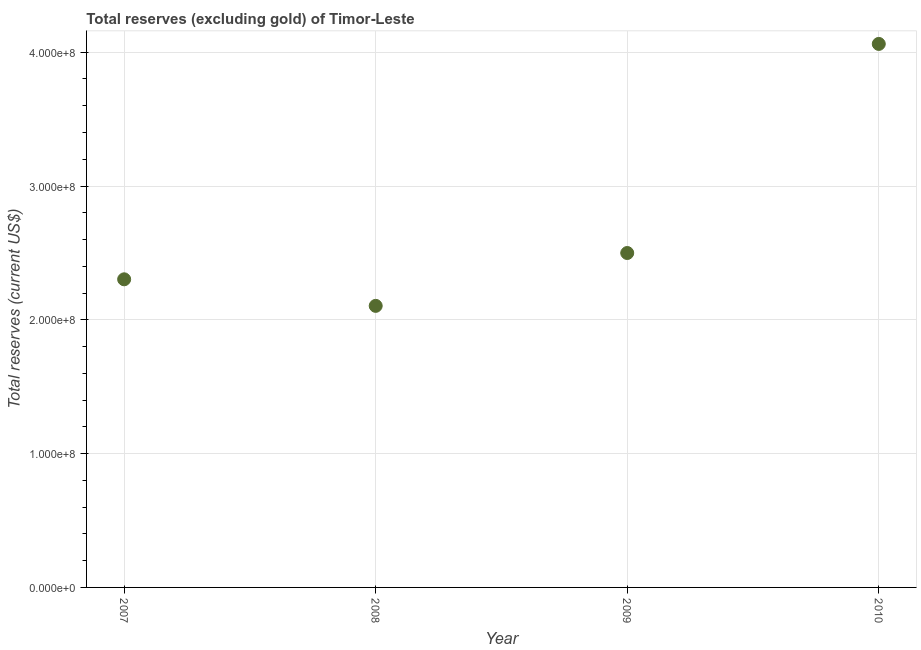What is the total reserves (excluding gold) in 2010?
Ensure brevity in your answer.  4.06e+08. Across all years, what is the maximum total reserves (excluding gold)?
Offer a terse response. 4.06e+08. Across all years, what is the minimum total reserves (excluding gold)?
Provide a short and direct response. 2.10e+08. In which year was the total reserves (excluding gold) maximum?
Keep it short and to the point. 2010. In which year was the total reserves (excluding gold) minimum?
Offer a terse response. 2008. What is the sum of the total reserves (excluding gold)?
Provide a succinct answer. 1.10e+09. What is the difference between the total reserves (excluding gold) in 2008 and 2010?
Keep it short and to the point. -1.96e+08. What is the average total reserves (excluding gold) per year?
Your answer should be compact. 2.74e+08. What is the median total reserves (excluding gold)?
Offer a terse response. 2.40e+08. In how many years, is the total reserves (excluding gold) greater than 360000000 US$?
Keep it short and to the point. 1. What is the ratio of the total reserves (excluding gold) in 2007 to that in 2010?
Offer a terse response. 0.57. Is the total reserves (excluding gold) in 2009 less than that in 2010?
Offer a terse response. Yes. What is the difference between the highest and the second highest total reserves (excluding gold)?
Offer a very short reply. 1.56e+08. Is the sum of the total reserves (excluding gold) in 2008 and 2010 greater than the maximum total reserves (excluding gold) across all years?
Provide a succinct answer. Yes. What is the difference between the highest and the lowest total reserves (excluding gold)?
Your answer should be very brief. 1.96e+08. Does the total reserves (excluding gold) monotonically increase over the years?
Provide a succinct answer. No. What is the difference between two consecutive major ticks on the Y-axis?
Keep it short and to the point. 1.00e+08. Does the graph contain any zero values?
Make the answer very short. No. What is the title of the graph?
Give a very brief answer. Total reserves (excluding gold) of Timor-Leste. What is the label or title of the X-axis?
Offer a terse response. Year. What is the label or title of the Y-axis?
Your answer should be very brief. Total reserves (current US$). What is the Total reserves (current US$) in 2007?
Keep it short and to the point. 2.30e+08. What is the Total reserves (current US$) in 2008?
Make the answer very short. 2.10e+08. What is the Total reserves (current US$) in 2009?
Give a very brief answer. 2.50e+08. What is the Total reserves (current US$) in 2010?
Offer a terse response. 4.06e+08. What is the difference between the Total reserves (current US$) in 2007 and 2008?
Offer a very short reply. 1.98e+07. What is the difference between the Total reserves (current US$) in 2007 and 2009?
Your response must be concise. -1.97e+07. What is the difference between the Total reserves (current US$) in 2007 and 2010?
Give a very brief answer. -1.76e+08. What is the difference between the Total reserves (current US$) in 2008 and 2009?
Provide a succinct answer. -3.95e+07. What is the difference between the Total reserves (current US$) in 2008 and 2010?
Make the answer very short. -1.96e+08. What is the difference between the Total reserves (current US$) in 2009 and 2010?
Your response must be concise. -1.56e+08. What is the ratio of the Total reserves (current US$) in 2007 to that in 2008?
Provide a short and direct response. 1.09. What is the ratio of the Total reserves (current US$) in 2007 to that in 2009?
Provide a succinct answer. 0.92. What is the ratio of the Total reserves (current US$) in 2007 to that in 2010?
Offer a very short reply. 0.57. What is the ratio of the Total reserves (current US$) in 2008 to that in 2009?
Keep it short and to the point. 0.84. What is the ratio of the Total reserves (current US$) in 2008 to that in 2010?
Offer a terse response. 0.52. What is the ratio of the Total reserves (current US$) in 2009 to that in 2010?
Ensure brevity in your answer.  0.61. 